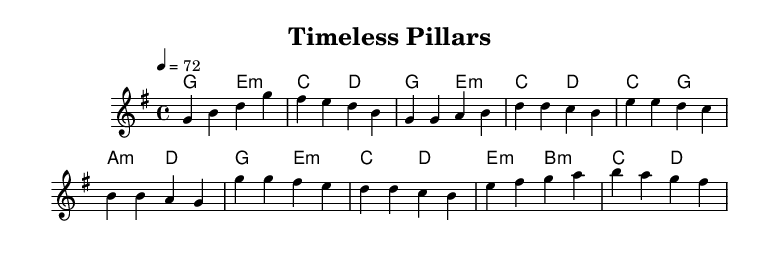What is the key signature of this music? The key signature is G major, which has one sharp (F#).
Answer: G major What is the time signature of this piece? The time signature is 4/4, indicating four beats in each measure and a quarter note receives one beat.
Answer: 4/4 What is the tempo marking of this piece? The tempo marking is "4 = 72," indicating that there are 72 quarter note beats per minute.
Answer: 72 How many measures are in the Intro section? The Intro consists of 2 measures, as indicated at the beginning of the score.
Answer: 2 measures What chords are used in the Chorus section? The chords in the Chorus section are G major, E minor, C major, and D major, which suggest a typical progression for K-Pop ballads.
Answer: G, E minor, C, D How does the melody of the Pre-Chorus differ from the Chorus in this piece? The melody of the Pre-Chorus utilizes the notes E, D, C, and B, while the Chorus primarily uses G, F#, E, D, C, and B, creating a gradual build-up in intensity.
Answer: Different notes, build-up What architectural theme might the music evoke based on its emotional tone? The melodic structure and harmonic progressions could evoke feelings of nostalgia or longing, which might be compared to the stories of historical buildings that stand as reminders of the past.
Answer: Nostalgia or longing 